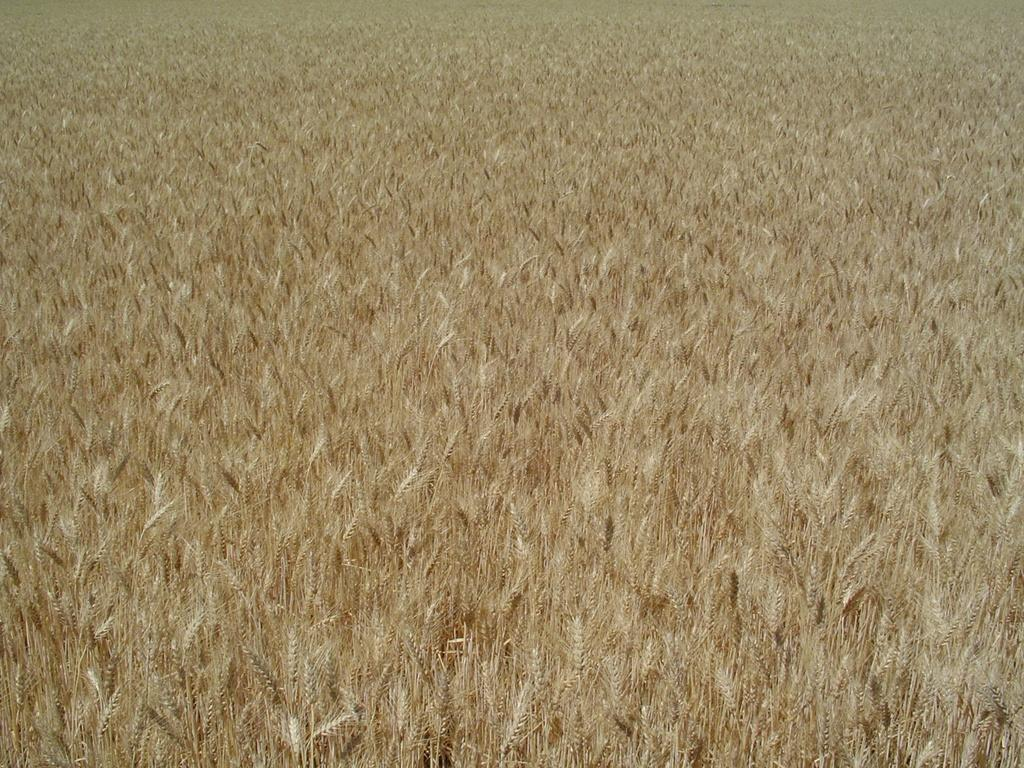What type of living organisms can be seen in the image? Plants can be seen in the image. What brand of toothpaste is visible in the image? There is no toothpaste present in the image; it only features plants. What type of grain can be seen growing among the plants in the image? There is no grain visible in the image; only plants are present. 